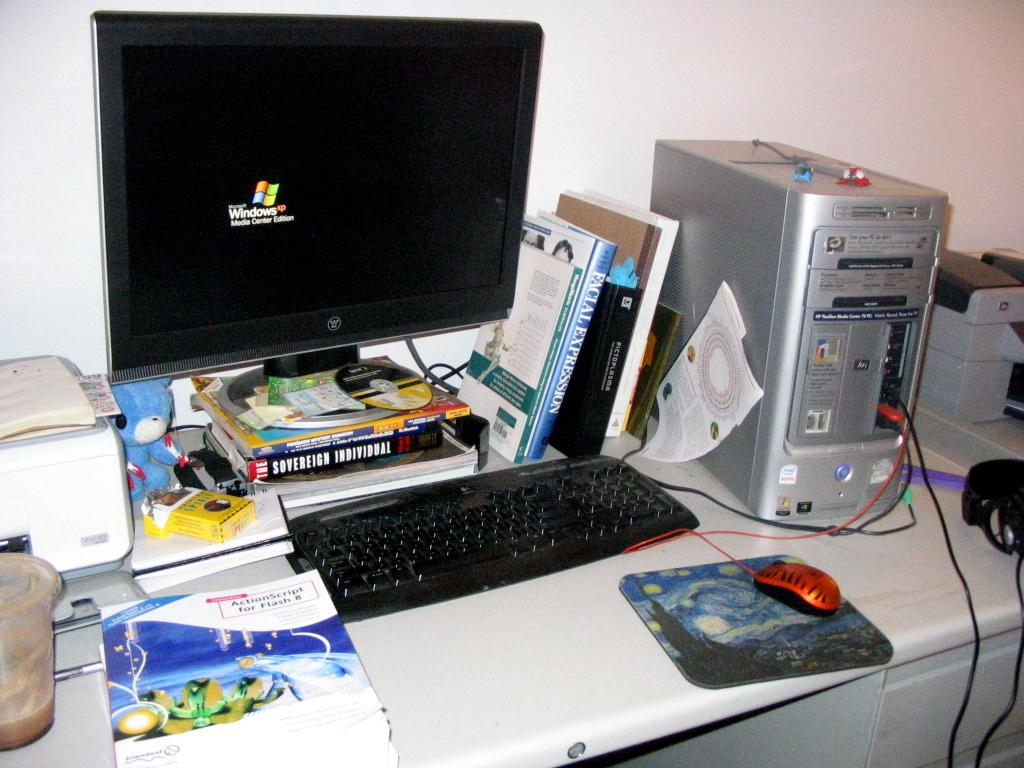<image>
Give a short and clear explanation of the subsequent image. An HP tower computer with a monitor and keyboard on a messy desk. 